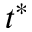<formula> <loc_0><loc_0><loc_500><loc_500>t ^ { * }</formula> 